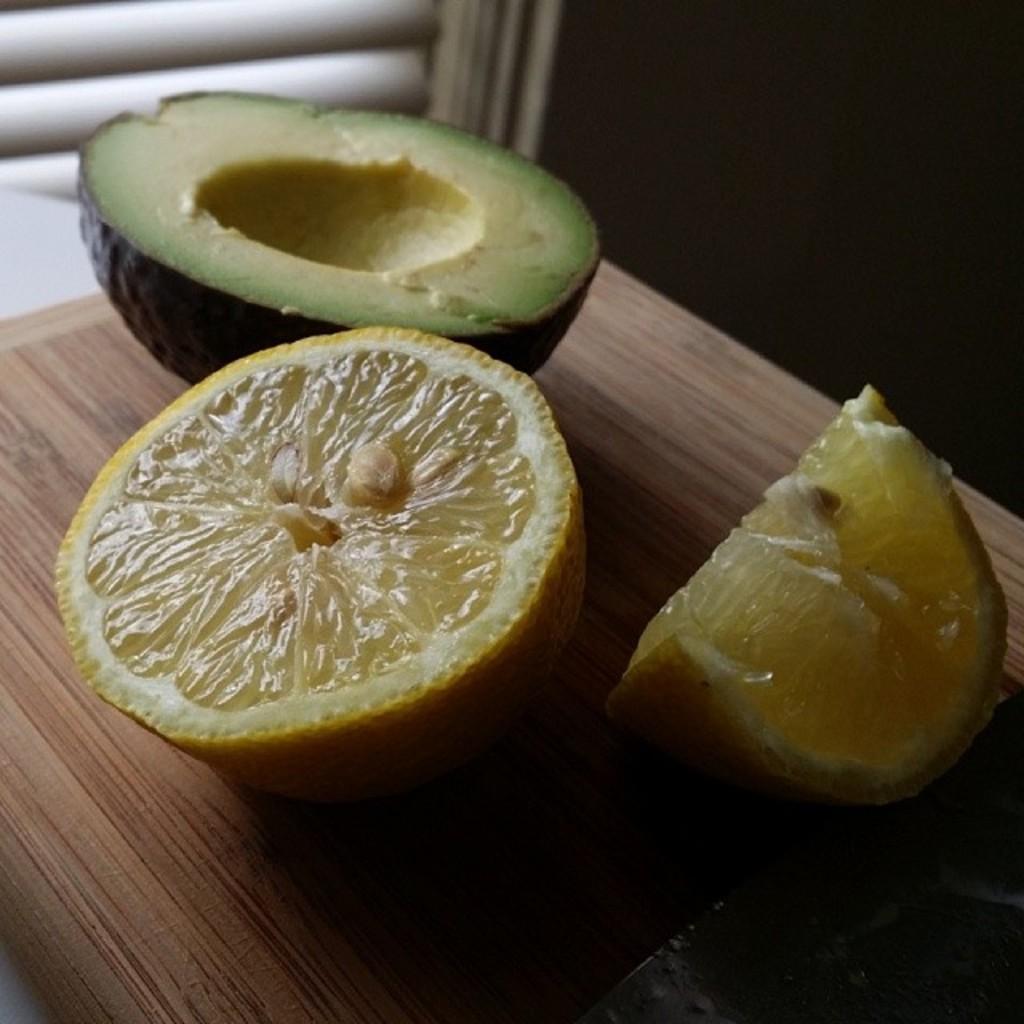How would you summarize this image in a sentence or two? There are pieces of orange and avocado on a wooden surface. 